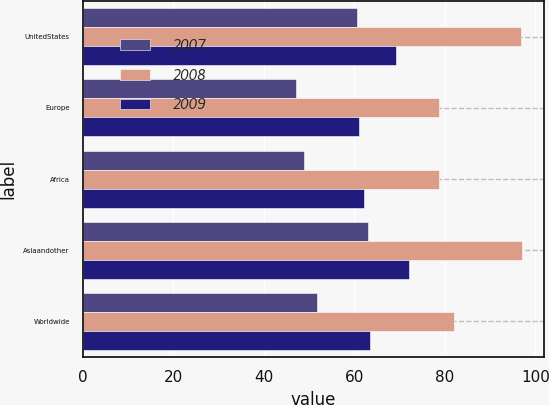<chart> <loc_0><loc_0><loc_500><loc_500><stacked_bar_chart><ecel><fcel>UnitedStates<fcel>Europe<fcel>Africa<fcel>Asiaandother<fcel>Worldwide<nl><fcel>2007<fcel>60.67<fcel>47.02<fcel>48.91<fcel>63.01<fcel>51.62<nl><fcel>2008<fcel>96.82<fcel>78.75<fcel>78.72<fcel>97.07<fcel>82.04<nl><fcel>2009<fcel>69.23<fcel>60.99<fcel>62.04<fcel>72.17<fcel>63.44<nl></chart> 